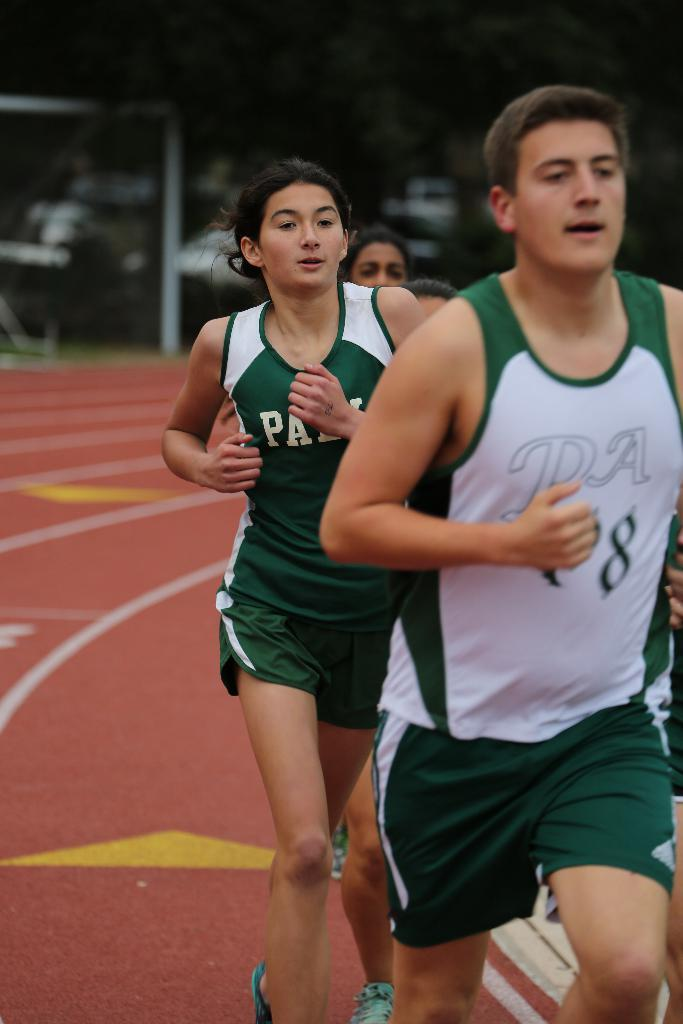<image>
Provide a brief description of the given image. A guy in a jersey with PA on it is running on a track. 